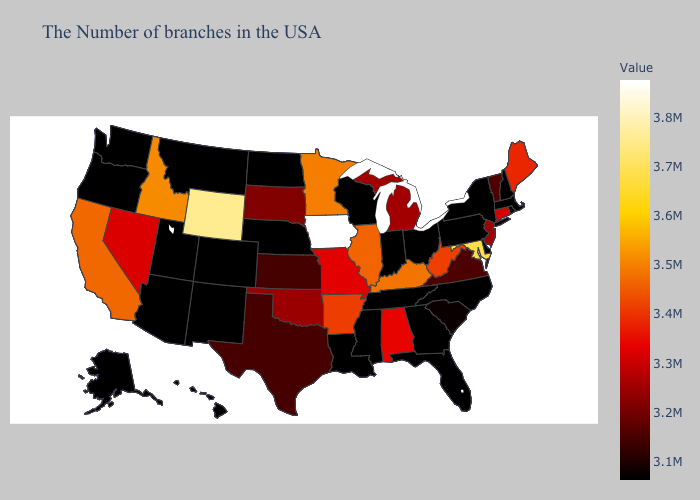Does Oklahoma have the lowest value in the USA?
Quick response, please. No. Among the states that border Missouri , does Kentucky have the highest value?
Give a very brief answer. No. Is the legend a continuous bar?
Concise answer only. Yes. Does Pennsylvania have the lowest value in the Northeast?
Write a very short answer. Yes. 